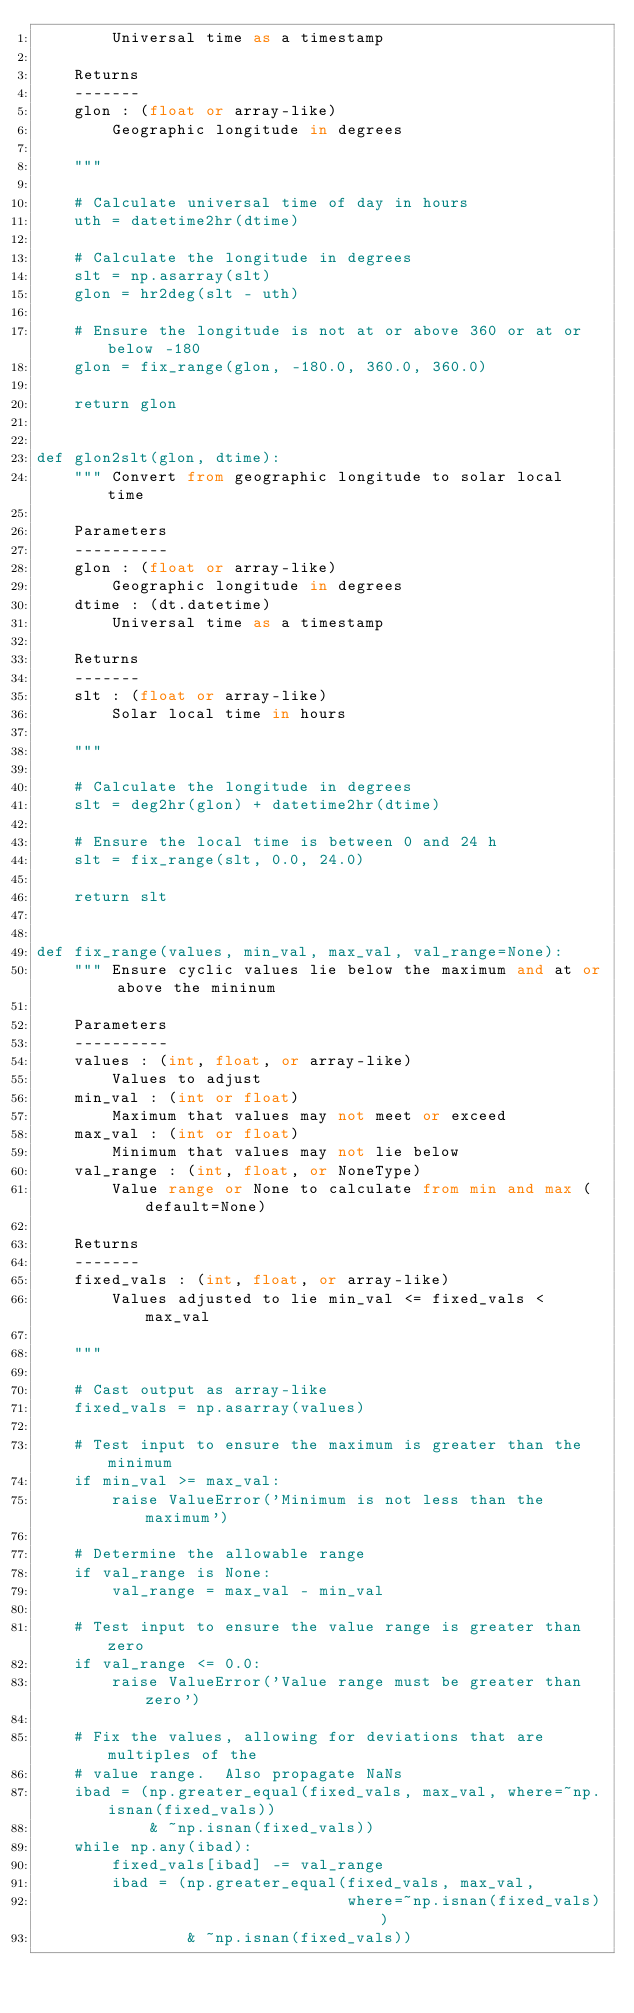<code> <loc_0><loc_0><loc_500><loc_500><_Python_>        Universal time as a timestamp

    Returns
    -------
    glon : (float or array-like)
        Geographic longitude in degrees

    """

    # Calculate universal time of day in hours
    uth = datetime2hr(dtime)

    # Calculate the longitude in degrees
    slt = np.asarray(slt)
    glon = hr2deg(slt - uth)

    # Ensure the longitude is not at or above 360 or at or below -180
    glon = fix_range(glon, -180.0, 360.0, 360.0)

    return glon


def glon2slt(glon, dtime):
    """ Convert from geographic longitude to solar local time

    Parameters
    ----------
    glon : (float or array-like)
        Geographic longitude in degrees
    dtime : (dt.datetime)
        Universal time as a timestamp

    Returns
    -------
    slt : (float or array-like)
        Solar local time in hours

    """

    # Calculate the longitude in degrees
    slt = deg2hr(glon) + datetime2hr(dtime)

    # Ensure the local time is between 0 and 24 h
    slt = fix_range(slt, 0.0, 24.0)

    return slt


def fix_range(values, min_val, max_val, val_range=None):
    """ Ensure cyclic values lie below the maximum and at or above the mininum

    Parameters
    ----------
    values : (int, float, or array-like)
        Values to adjust
    min_val : (int or float)
        Maximum that values may not meet or exceed
    max_val : (int or float)
        Minimum that values may not lie below
    val_range : (int, float, or NoneType)
        Value range or None to calculate from min and max (default=None)

    Returns
    -------
    fixed_vals : (int, float, or array-like)
        Values adjusted to lie min_val <= fixed_vals < max_val

    """

    # Cast output as array-like
    fixed_vals = np.asarray(values)

    # Test input to ensure the maximum is greater than the minimum
    if min_val >= max_val:
        raise ValueError('Minimum is not less than the maximum')

    # Determine the allowable range
    if val_range is None:
        val_range = max_val - min_val

    # Test input to ensure the value range is greater than zero
    if val_range <= 0.0:
        raise ValueError('Value range must be greater than zero')

    # Fix the values, allowing for deviations that are multiples of the
    # value range.  Also propagate NaNs
    ibad = (np.greater_equal(fixed_vals, max_val, where=~np.isnan(fixed_vals))
            & ~np.isnan(fixed_vals))
    while np.any(ibad):
        fixed_vals[ibad] -= val_range
        ibad = (np.greater_equal(fixed_vals, max_val,
                                 where=~np.isnan(fixed_vals))
                & ~np.isnan(fixed_vals))
</code> 